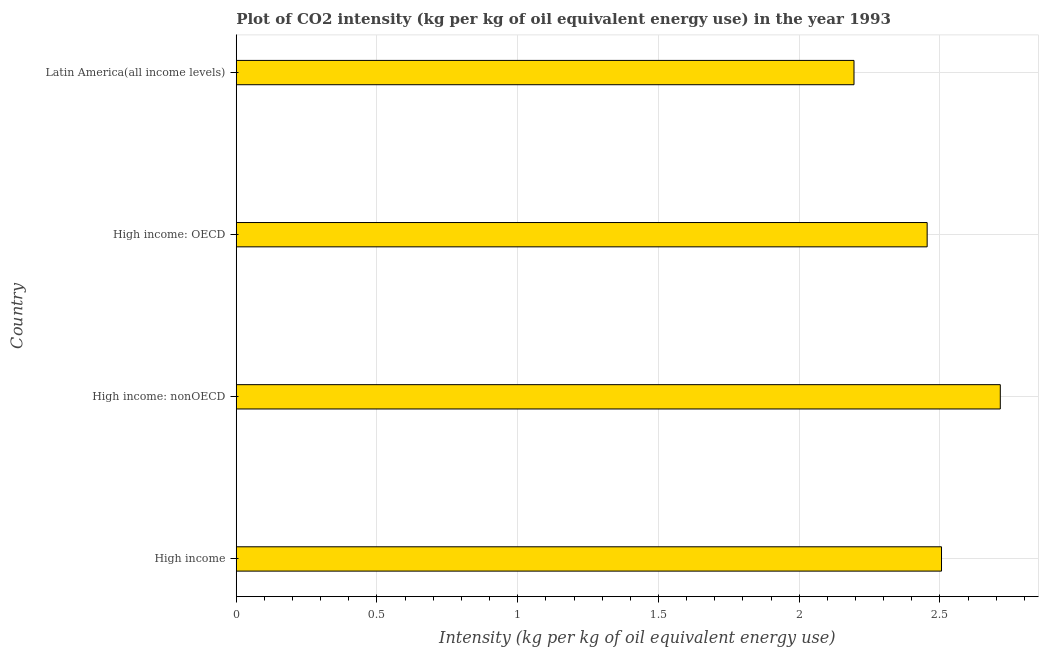Does the graph contain any zero values?
Your answer should be very brief. No. What is the title of the graph?
Offer a very short reply. Plot of CO2 intensity (kg per kg of oil equivalent energy use) in the year 1993. What is the label or title of the X-axis?
Your answer should be very brief. Intensity (kg per kg of oil equivalent energy use). What is the label or title of the Y-axis?
Ensure brevity in your answer.  Country. What is the co2 intensity in Latin America(all income levels)?
Provide a short and direct response. 2.19. Across all countries, what is the maximum co2 intensity?
Your response must be concise. 2.71. Across all countries, what is the minimum co2 intensity?
Your response must be concise. 2.19. In which country was the co2 intensity maximum?
Provide a short and direct response. High income: nonOECD. In which country was the co2 intensity minimum?
Your answer should be compact. Latin America(all income levels). What is the sum of the co2 intensity?
Your answer should be very brief. 9.87. What is the difference between the co2 intensity in High income and Latin America(all income levels)?
Offer a very short reply. 0.31. What is the average co2 intensity per country?
Offer a very short reply. 2.47. What is the median co2 intensity?
Make the answer very short. 2.48. In how many countries, is the co2 intensity greater than 0.9 kg?
Offer a very short reply. 4. What is the ratio of the co2 intensity in High income: nonOECD to that in Latin America(all income levels)?
Your answer should be very brief. 1.24. What is the difference between the highest and the second highest co2 intensity?
Give a very brief answer. 0.21. Is the sum of the co2 intensity in High income: nonOECD and Latin America(all income levels) greater than the maximum co2 intensity across all countries?
Offer a very short reply. Yes. What is the difference between the highest and the lowest co2 intensity?
Ensure brevity in your answer.  0.52. In how many countries, is the co2 intensity greater than the average co2 intensity taken over all countries?
Offer a very short reply. 2. How many bars are there?
Give a very brief answer. 4. How many countries are there in the graph?
Offer a terse response. 4. Are the values on the major ticks of X-axis written in scientific E-notation?
Provide a short and direct response. No. What is the Intensity (kg per kg of oil equivalent energy use) of High income?
Make the answer very short. 2.51. What is the Intensity (kg per kg of oil equivalent energy use) of High income: nonOECD?
Your answer should be compact. 2.71. What is the Intensity (kg per kg of oil equivalent energy use) in High income: OECD?
Provide a succinct answer. 2.45. What is the Intensity (kg per kg of oil equivalent energy use) of Latin America(all income levels)?
Ensure brevity in your answer.  2.19. What is the difference between the Intensity (kg per kg of oil equivalent energy use) in High income and High income: nonOECD?
Your response must be concise. -0.21. What is the difference between the Intensity (kg per kg of oil equivalent energy use) in High income and High income: OECD?
Offer a very short reply. 0.05. What is the difference between the Intensity (kg per kg of oil equivalent energy use) in High income and Latin America(all income levels)?
Provide a short and direct response. 0.31. What is the difference between the Intensity (kg per kg of oil equivalent energy use) in High income: nonOECD and High income: OECD?
Provide a succinct answer. 0.26. What is the difference between the Intensity (kg per kg of oil equivalent energy use) in High income: nonOECD and Latin America(all income levels)?
Offer a terse response. 0.52. What is the difference between the Intensity (kg per kg of oil equivalent energy use) in High income: OECD and Latin America(all income levels)?
Offer a terse response. 0.26. What is the ratio of the Intensity (kg per kg of oil equivalent energy use) in High income to that in High income: nonOECD?
Offer a very short reply. 0.92. What is the ratio of the Intensity (kg per kg of oil equivalent energy use) in High income to that in High income: OECD?
Your response must be concise. 1.02. What is the ratio of the Intensity (kg per kg of oil equivalent energy use) in High income to that in Latin America(all income levels)?
Give a very brief answer. 1.14. What is the ratio of the Intensity (kg per kg of oil equivalent energy use) in High income: nonOECD to that in High income: OECD?
Your answer should be compact. 1.11. What is the ratio of the Intensity (kg per kg of oil equivalent energy use) in High income: nonOECD to that in Latin America(all income levels)?
Offer a very short reply. 1.24. What is the ratio of the Intensity (kg per kg of oil equivalent energy use) in High income: OECD to that in Latin America(all income levels)?
Your response must be concise. 1.12. 